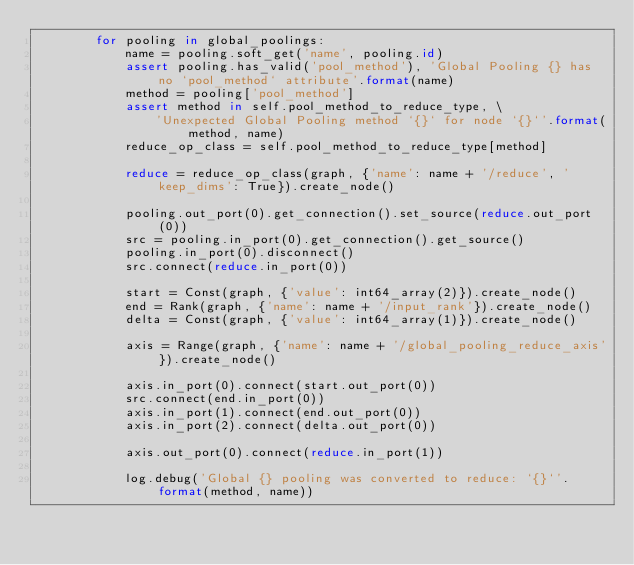<code> <loc_0><loc_0><loc_500><loc_500><_Python_>        for pooling in global_poolings:
            name = pooling.soft_get('name', pooling.id)
            assert pooling.has_valid('pool_method'), 'Global Pooling {} has no `pool_method` attribute'.format(name)
            method = pooling['pool_method']
            assert method in self.pool_method_to_reduce_type, \
                'Unexpected Global Pooling method `{}` for node `{}`'.format(method, name)
            reduce_op_class = self.pool_method_to_reduce_type[method]

            reduce = reduce_op_class(graph, {'name': name + '/reduce', 'keep_dims': True}).create_node()

            pooling.out_port(0).get_connection().set_source(reduce.out_port(0))
            src = pooling.in_port(0).get_connection().get_source()
            pooling.in_port(0).disconnect()
            src.connect(reduce.in_port(0))

            start = Const(graph, {'value': int64_array(2)}).create_node()
            end = Rank(graph, {'name': name + '/input_rank'}).create_node()
            delta = Const(graph, {'value': int64_array(1)}).create_node()

            axis = Range(graph, {'name': name + '/global_pooling_reduce_axis'}).create_node()

            axis.in_port(0).connect(start.out_port(0))
            src.connect(end.in_port(0))
            axis.in_port(1).connect(end.out_port(0))
            axis.in_port(2).connect(delta.out_port(0))

            axis.out_port(0).connect(reduce.in_port(1))

            log.debug('Global {} pooling was converted to reduce: `{}`'.format(method, name))
</code> 